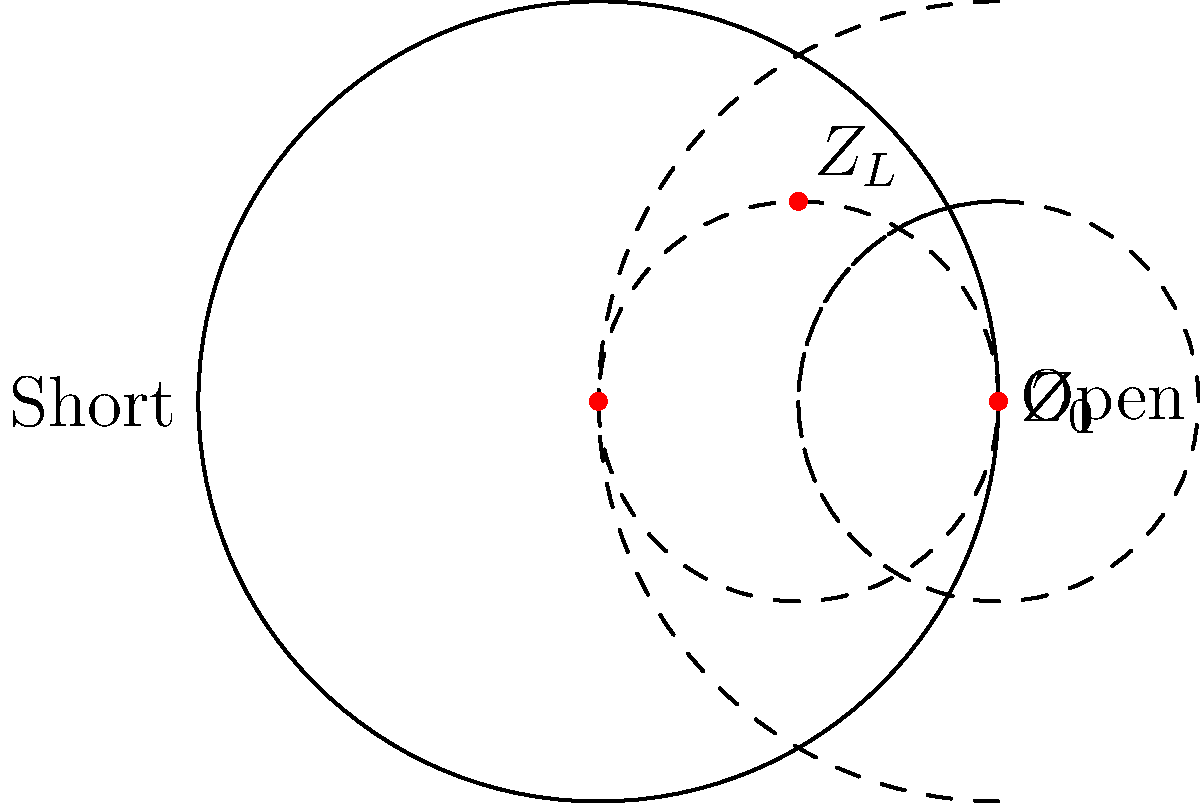In a transmission line system with a characteristic impedance $Z_0 = 50\Omega$, you need to match a load impedance $Z_L$ to minimize reflections. Using the Smith chart provided, determine the normalized impedance $z_L = Z_L/Z_0$ if the load is located at the point (0.5, 0.5) on the chart. How does this relate to the concept of transubstantiation in Catholic theology? To solve this problem, we'll follow these steps:

1. Understand the Smith chart:
   - The Smith chart is a graphical tool used to solve transmission line problems.
   - The horizontal axis represents the real part of the impedance, and the circular arcs represent the imaginary part.

2. Locate the load impedance:
   - The given point (0.5, 0.5) on the Smith chart represents the normalized load impedance $z_L$.

3. Interpret the normalized impedance:
   - The real part (resistance) is read from the constant resistance circles.
   - The imaginary part (reactance) is read from the constant reactance arcs.

4. Determine the normalized impedance:
   - At point (0.5, 0.5), we can see that:
     - The resistance is approximately 1.5
     - The reactance is approximately +0.5

5. Express the normalized impedance:
   $z_L = 1.5 + j0.5$

6. Calculate the actual load impedance:
   $Z_L = z_L \cdot Z_0 = (1.5 + j0.5) \cdot 50\Omega = 75\Omega + j25\Omega$

Relating to Catholic theology:
Just as the Smith chart helps us transform and match impedances in electrical engineering, the concept of transubstantiation in Catholic theology involves a transformation of bread and wine into the body and blood of Christ. Both concepts deal with changes that are not immediately apparent to the senses but are believed to be real transformations.
Answer: $Z_L = 75\Omega + j25\Omega$ 